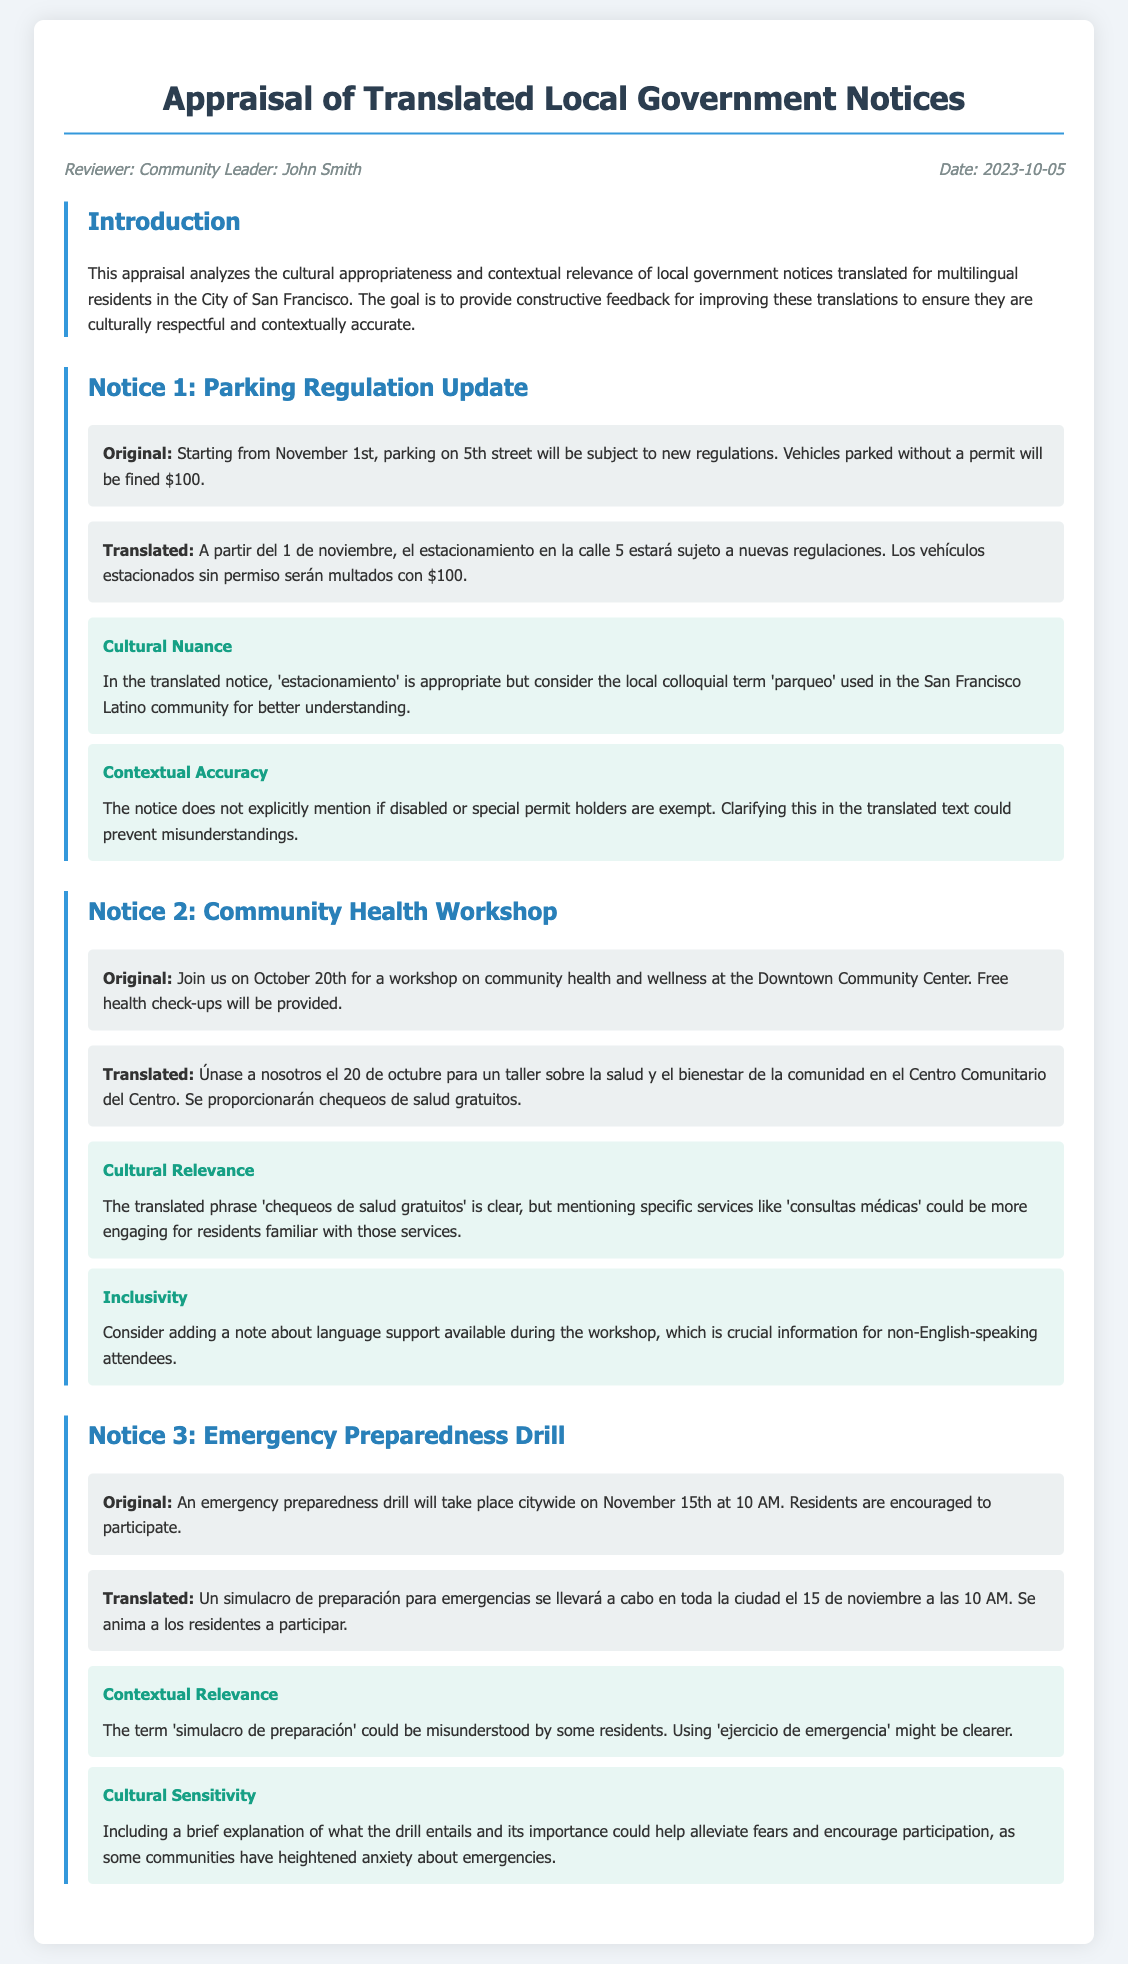what is the name of the reviewer? The reviewer is identified as "Community Leader: John Smith" in the header information.
Answer: John Smith what is the document date? The date is listed in the header as when the appraisal was done.
Answer: 2023-10-05 how many notices are included in the appraisal? The document details three notices, each with its own section for appraisal.
Answer: 3 what is the new parking fine amount mentioned? The fine amount for parking without a permit is stated in the original notice.
Answer: $100 what is a suggested term for parking according to the feedback? The feedback suggests a colloquial term used in the local Latino community.
Answer: parqueo what is the date of the community health workshop? The workshop date is provided in the original notice for community health.
Answer: October 20th what service is mentioned as being provided for free at the workshop? The notice states a specific type of service offered during the workshop.
Answer: health check-ups what is the date of the emergency preparedness drill? The drill date is included in the original emergency preparedness notice.
Answer: November 15th what alternative term is suggested for 'simulacro de preparación'? The feedback offers a clearer alternative phrase to avoid confusion.
Answer: ejercicio de emergencia 